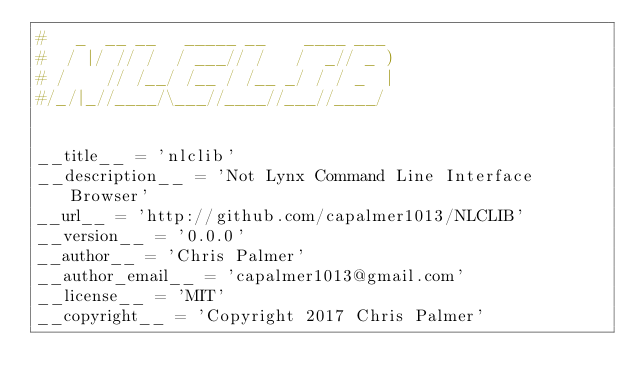Convert code to text. <code><loc_0><loc_0><loc_500><loc_500><_Python_>#   _  __ __   _____ __    ____ ___ 
#  / |/ // /  / ___// /   /  _// _ )
# /    // /__/ /__ / /__ _/ / / _  |
#/_/|_//____/\___//____//___//____/ 


__title__ = 'nlclib'
__description__ = 'Not Lynx Command Line Interface Browser'
__url__ = 'http://github.com/capalmer1013/NLCLIB'
__version__ = '0.0.0'
__author__ = 'Chris Palmer'
__author_email__ = 'capalmer1013@gmail.com'
__license__ = 'MIT'
__copyright__ = 'Copyright 2017 Chris Palmer'
</code> 